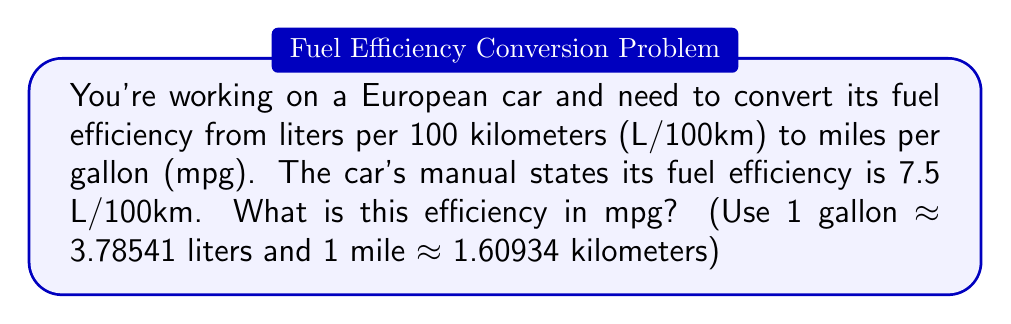Could you help me with this problem? Let's break this down step-by-step:

1) First, we need to understand what 7.5 L/100km means:
   It takes 7.5 liters of fuel to drive 100 kilometers.

2) To convert to mpg, we need to find out how many miles we can drive with 1 gallon.

3) Let's start by finding how many kilometers we can drive with 1 gallon:
   $$ \frac{100 \text{ km}}{7.5 \text{ L}} \times 3.78541 \text{ L/gal} = 50.47213 \text{ km/gal} $$

4) Now, let's convert kilometers to miles:
   $$ 50.47213 \text{ km/gal} \div 1.60934 \text{ km/mi} = 31.36214 \text{ mi/gal} $$

5) Rounding to the nearest tenth:
   $$ 31.36214 \text{ mi/gal} \approx 31.4 \text{ mpg} $$
Answer: 31.4 mpg 